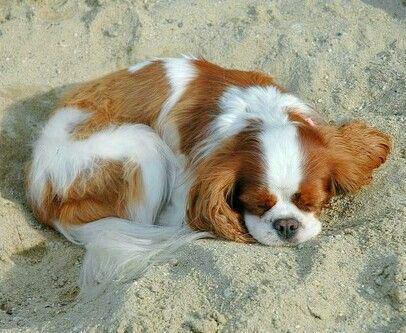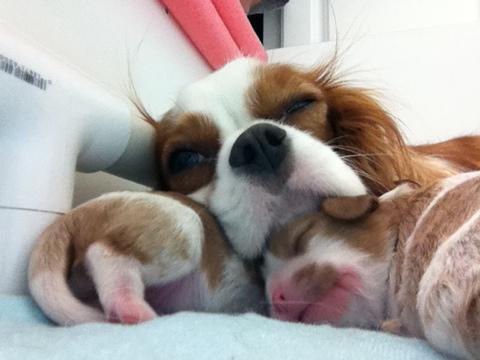The first image is the image on the left, the second image is the image on the right. Analyze the images presented: Is the assertion "In one of the image there are puppies near an adult dog." valid? Answer yes or no. Yes. The first image is the image on the left, the second image is the image on the right. Assess this claim about the two images: "The left image has no more than one dog laying down.". Correct or not? Answer yes or no. Yes. 